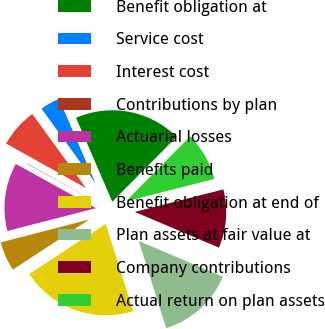<chart> <loc_0><loc_0><loc_500><loc_500><pie_chart><fcel>Benefit obligation at<fcel>Service cost<fcel>Interest cost<fcel>Contributions by plan<fcel>Actuarial losses<fcel>Benefits paid<fcel>Benefit obligation at end of<fcel>Plan assets at fair value at<fcel>Company contributions<fcel>Actual return on plan assets<nl><fcel>18.9%<fcel>3.5%<fcel>6.92%<fcel>0.07%<fcel>12.05%<fcel>5.21%<fcel>20.61%<fcel>13.77%<fcel>10.34%<fcel>8.63%<nl></chart> 